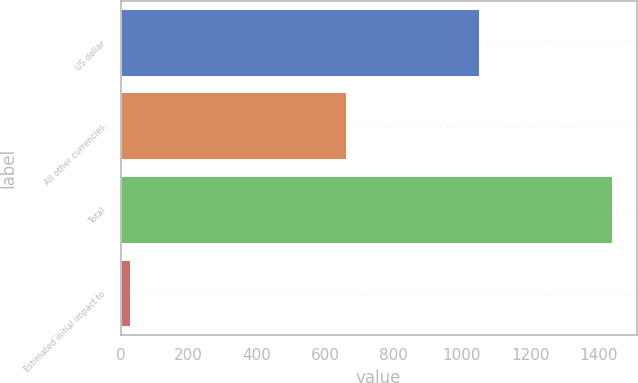Convert chart to OTSL. <chart><loc_0><loc_0><loc_500><loc_500><bar_chart><fcel>US dollar<fcel>All other currencies<fcel>Total<fcel>Estimated initial impact to<nl><fcel>1050.2<fcel>661<fcel>1439.4<fcel>28<nl></chart> 